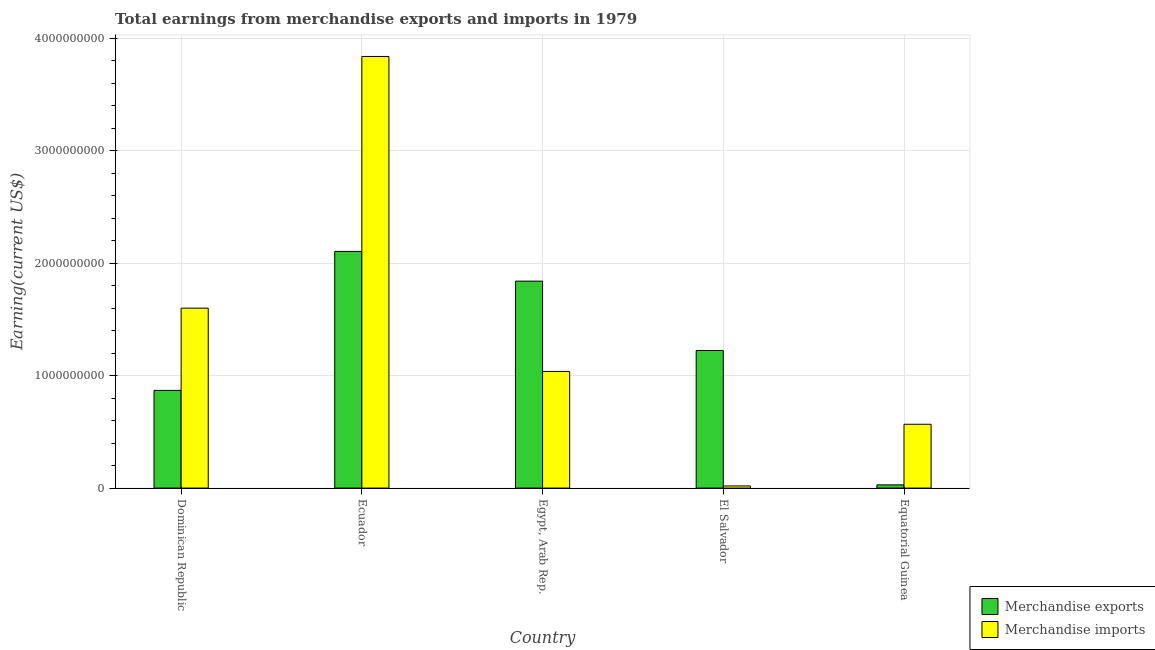How many groups of bars are there?
Your answer should be very brief. 5. What is the label of the 5th group of bars from the left?
Offer a very short reply. Equatorial Guinea. In how many cases, is the number of bars for a given country not equal to the number of legend labels?
Provide a succinct answer. 0. What is the earnings from merchandise imports in Equatorial Guinea?
Offer a terse response. 5.67e+08. Across all countries, what is the maximum earnings from merchandise exports?
Ensure brevity in your answer.  2.10e+09. Across all countries, what is the minimum earnings from merchandise imports?
Your answer should be compact. 1.91e+07. In which country was the earnings from merchandise exports maximum?
Make the answer very short. Ecuador. In which country was the earnings from merchandise imports minimum?
Give a very brief answer. El Salvador. What is the total earnings from merchandise exports in the graph?
Give a very brief answer. 6.06e+09. What is the difference between the earnings from merchandise exports in Ecuador and that in Egypt, Arab Rep.?
Give a very brief answer. 2.64e+08. What is the difference between the earnings from merchandise exports in El Salvador and the earnings from merchandise imports in Dominican Republic?
Provide a succinct answer. -3.77e+08. What is the average earnings from merchandise exports per country?
Give a very brief answer. 1.21e+09. What is the difference between the earnings from merchandise exports and earnings from merchandise imports in Equatorial Guinea?
Provide a succinct answer. -5.39e+08. What is the ratio of the earnings from merchandise imports in Dominican Republic to that in Equatorial Guinea?
Ensure brevity in your answer.  2.82. What is the difference between the highest and the second highest earnings from merchandise imports?
Provide a short and direct response. 2.24e+09. What is the difference between the highest and the lowest earnings from merchandise imports?
Offer a very short reply. 3.82e+09. In how many countries, is the earnings from merchandise imports greater than the average earnings from merchandise imports taken over all countries?
Your answer should be compact. 2. Is the sum of the earnings from merchandise exports in Ecuador and Egypt, Arab Rep. greater than the maximum earnings from merchandise imports across all countries?
Offer a terse response. Yes. What does the 1st bar from the right in Egypt, Arab Rep. represents?
Give a very brief answer. Merchandise imports. Are all the bars in the graph horizontal?
Your response must be concise. No. How many countries are there in the graph?
Ensure brevity in your answer.  5. Are the values on the major ticks of Y-axis written in scientific E-notation?
Your response must be concise. No. Does the graph contain any zero values?
Provide a succinct answer. No. Does the graph contain grids?
Keep it short and to the point. Yes. How many legend labels are there?
Ensure brevity in your answer.  2. How are the legend labels stacked?
Offer a terse response. Vertical. What is the title of the graph?
Your response must be concise. Total earnings from merchandise exports and imports in 1979. Does "Birth rate" appear as one of the legend labels in the graph?
Keep it short and to the point. No. What is the label or title of the X-axis?
Your answer should be compact. Country. What is the label or title of the Y-axis?
Provide a succinct answer. Earning(current US$). What is the Earning(current US$) of Merchandise exports in Dominican Republic?
Give a very brief answer. 8.69e+08. What is the Earning(current US$) of Merchandise imports in Dominican Republic?
Ensure brevity in your answer.  1.60e+09. What is the Earning(current US$) in Merchandise exports in Ecuador?
Your answer should be very brief. 2.10e+09. What is the Earning(current US$) in Merchandise imports in Ecuador?
Keep it short and to the point. 3.84e+09. What is the Earning(current US$) of Merchandise exports in Egypt, Arab Rep.?
Give a very brief answer. 1.84e+09. What is the Earning(current US$) of Merchandise imports in Egypt, Arab Rep.?
Your response must be concise. 1.04e+09. What is the Earning(current US$) in Merchandise exports in El Salvador?
Give a very brief answer. 1.22e+09. What is the Earning(current US$) in Merchandise imports in El Salvador?
Provide a succinct answer. 1.91e+07. What is the Earning(current US$) of Merchandise exports in Equatorial Guinea?
Offer a terse response. 2.87e+07. What is the Earning(current US$) of Merchandise imports in Equatorial Guinea?
Provide a succinct answer. 5.67e+08. Across all countries, what is the maximum Earning(current US$) of Merchandise exports?
Provide a short and direct response. 2.10e+09. Across all countries, what is the maximum Earning(current US$) in Merchandise imports?
Your response must be concise. 3.84e+09. Across all countries, what is the minimum Earning(current US$) of Merchandise exports?
Offer a terse response. 2.87e+07. Across all countries, what is the minimum Earning(current US$) in Merchandise imports?
Ensure brevity in your answer.  1.91e+07. What is the total Earning(current US$) in Merchandise exports in the graph?
Your answer should be compact. 6.06e+09. What is the total Earning(current US$) in Merchandise imports in the graph?
Your answer should be compact. 7.06e+09. What is the difference between the Earning(current US$) of Merchandise exports in Dominican Republic and that in Ecuador?
Keep it short and to the point. -1.24e+09. What is the difference between the Earning(current US$) in Merchandise imports in Dominican Republic and that in Ecuador?
Offer a terse response. -2.24e+09. What is the difference between the Earning(current US$) in Merchandise exports in Dominican Republic and that in Egypt, Arab Rep.?
Your answer should be very brief. -9.71e+08. What is the difference between the Earning(current US$) in Merchandise imports in Dominican Republic and that in Egypt, Arab Rep.?
Give a very brief answer. 5.63e+08. What is the difference between the Earning(current US$) of Merchandise exports in Dominican Republic and that in El Salvador?
Provide a succinct answer. -3.55e+08. What is the difference between the Earning(current US$) in Merchandise imports in Dominican Republic and that in El Salvador?
Give a very brief answer. 1.58e+09. What is the difference between the Earning(current US$) in Merchandise exports in Dominican Republic and that in Equatorial Guinea?
Provide a short and direct response. 8.40e+08. What is the difference between the Earning(current US$) in Merchandise imports in Dominican Republic and that in Equatorial Guinea?
Provide a succinct answer. 1.03e+09. What is the difference between the Earning(current US$) in Merchandise exports in Ecuador and that in Egypt, Arab Rep.?
Make the answer very short. 2.64e+08. What is the difference between the Earning(current US$) in Merchandise imports in Ecuador and that in Egypt, Arab Rep.?
Make the answer very short. 2.80e+09. What is the difference between the Earning(current US$) in Merchandise exports in Ecuador and that in El Salvador?
Your answer should be very brief. 8.81e+08. What is the difference between the Earning(current US$) in Merchandise imports in Ecuador and that in El Salvador?
Give a very brief answer. 3.82e+09. What is the difference between the Earning(current US$) in Merchandise exports in Ecuador and that in Equatorial Guinea?
Provide a short and direct response. 2.08e+09. What is the difference between the Earning(current US$) in Merchandise imports in Ecuador and that in Equatorial Guinea?
Ensure brevity in your answer.  3.27e+09. What is the difference between the Earning(current US$) of Merchandise exports in Egypt, Arab Rep. and that in El Salvador?
Make the answer very short. 6.17e+08. What is the difference between the Earning(current US$) of Merchandise imports in Egypt, Arab Rep. and that in El Salvador?
Your response must be concise. 1.02e+09. What is the difference between the Earning(current US$) in Merchandise exports in Egypt, Arab Rep. and that in Equatorial Guinea?
Make the answer very short. 1.81e+09. What is the difference between the Earning(current US$) in Merchandise imports in Egypt, Arab Rep. and that in Equatorial Guinea?
Keep it short and to the point. 4.70e+08. What is the difference between the Earning(current US$) of Merchandise exports in El Salvador and that in Equatorial Guinea?
Provide a succinct answer. 1.19e+09. What is the difference between the Earning(current US$) of Merchandise imports in El Salvador and that in Equatorial Guinea?
Your answer should be very brief. -5.48e+08. What is the difference between the Earning(current US$) of Merchandise exports in Dominican Republic and the Earning(current US$) of Merchandise imports in Ecuador?
Offer a very short reply. -2.97e+09. What is the difference between the Earning(current US$) of Merchandise exports in Dominican Republic and the Earning(current US$) of Merchandise imports in Egypt, Arab Rep.?
Provide a short and direct response. -1.68e+08. What is the difference between the Earning(current US$) of Merchandise exports in Dominican Republic and the Earning(current US$) of Merchandise imports in El Salvador?
Your response must be concise. 8.49e+08. What is the difference between the Earning(current US$) of Merchandise exports in Dominican Republic and the Earning(current US$) of Merchandise imports in Equatorial Guinea?
Your answer should be very brief. 3.01e+08. What is the difference between the Earning(current US$) in Merchandise exports in Ecuador and the Earning(current US$) in Merchandise imports in Egypt, Arab Rep.?
Your answer should be very brief. 1.07e+09. What is the difference between the Earning(current US$) of Merchandise exports in Ecuador and the Earning(current US$) of Merchandise imports in El Salvador?
Make the answer very short. 2.09e+09. What is the difference between the Earning(current US$) in Merchandise exports in Ecuador and the Earning(current US$) in Merchandise imports in Equatorial Guinea?
Provide a succinct answer. 1.54e+09. What is the difference between the Earning(current US$) in Merchandise exports in Egypt, Arab Rep. and the Earning(current US$) in Merchandise imports in El Salvador?
Offer a terse response. 1.82e+09. What is the difference between the Earning(current US$) of Merchandise exports in Egypt, Arab Rep. and the Earning(current US$) of Merchandise imports in Equatorial Guinea?
Provide a succinct answer. 1.27e+09. What is the difference between the Earning(current US$) in Merchandise exports in El Salvador and the Earning(current US$) in Merchandise imports in Equatorial Guinea?
Ensure brevity in your answer.  6.56e+08. What is the average Earning(current US$) in Merchandise exports per country?
Make the answer very short. 1.21e+09. What is the average Earning(current US$) of Merchandise imports per country?
Your answer should be compact. 1.41e+09. What is the difference between the Earning(current US$) in Merchandise exports and Earning(current US$) in Merchandise imports in Dominican Republic?
Your answer should be very brief. -7.31e+08. What is the difference between the Earning(current US$) in Merchandise exports and Earning(current US$) in Merchandise imports in Ecuador?
Your answer should be very brief. -1.73e+09. What is the difference between the Earning(current US$) of Merchandise exports and Earning(current US$) of Merchandise imports in Egypt, Arab Rep.?
Your answer should be compact. 8.03e+08. What is the difference between the Earning(current US$) of Merchandise exports and Earning(current US$) of Merchandise imports in El Salvador?
Give a very brief answer. 1.20e+09. What is the difference between the Earning(current US$) in Merchandise exports and Earning(current US$) in Merchandise imports in Equatorial Guinea?
Make the answer very short. -5.39e+08. What is the ratio of the Earning(current US$) of Merchandise exports in Dominican Republic to that in Ecuador?
Your answer should be compact. 0.41. What is the ratio of the Earning(current US$) of Merchandise imports in Dominican Republic to that in Ecuador?
Give a very brief answer. 0.42. What is the ratio of the Earning(current US$) of Merchandise exports in Dominican Republic to that in Egypt, Arab Rep.?
Your answer should be very brief. 0.47. What is the ratio of the Earning(current US$) in Merchandise imports in Dominican Republic to that in Egypt, Arab Rep.?
Provide a succinct answer. 1.54. What is the ratio of the Earning(current US$) of Merchandise exports in Dominican Republic to that in El Salvador?
Keep it short and to the point. 0.71. What is the ratio of the Earning(current US$) of Merchandise imports in Dominican Republic to that in El Salvador?
Offer a very short reply. 83.71. What is the ratio of the Earning(current US$) in Merchandise exports in Dominican Republic to that in Equatorial Guinea?
Make the answer very short. 30.24. What is the ratio of the Earning(current US$) of Merchandise imports in Dominican Republic to that in Equatorial Guinea?
Make the answer very short. 2.82. What is the ratio of the Earning(current US$) in Merchandise exports in Ecuador to that in Egypt, Arab Rep.?
Offer a terse response. 1.14. What is the ratio of the Earning(current US$) in Merchandise imports in Ecuador to that in Egypt, Arab Rep.?
Ensure brevity in your answer.  3.7. What is the ratio of the Earning(current US$) in Merchandise exports in Ecuador to that in El Salvador?
Provide a succinct answer. 1.72. What is the ratio of the Earning(current US$) of Merchandise imports in Ecuador to that in El Salvador?
Offer a very short reply. 200.79. What is the ratio of the Earning(current US$) of Merchandise exports in Ecuador to that in Equatorial Guinea?
Your response must be concise. 73.27. What is the ratio of the Earning(current US$) in Merchandise imports in Ecuador to that in Equatorial Guinea?
Provide a succinct answer. 6.76. What is the ratio of the Earning(current US$) in Merchandise exports in Egypt, Arab Rep. to that in El Salvador?
Offer a very short reply. 1.5. What is the ratio of the Earning(current US$) of Merchandise imports in Egypt, Arab Rep. to that in El Salvador?
Make the answer very short. 54.27. What is the ratio of the Earning(current US$) of Merchandise exports in Egypt, Arab Rep. to that in Equatorial Guinea?
Provide a short and direct response. 64.06. What is the ratio of the Earning(current US$) of Merchandise imports in Egypt, Arab Rep. to that in Equatorial Guinea?
Provide a succinct answer. 1.83. What is the ratio of the Earning(current US$) of Merchandise exports in El Salvador to that in Equatorial Guinea?
Offer a very short reply. 42.59. What is the ratio of the Earning(current US$) of Merchandise imports in El Salvador to that in Equatorial Guinea?
Give a very brief answer. 0.03. What is the difference between the highest and the second highest Earning(current US$) of Merchandise exports?
Offer a terse response. 2.64e+08. What is the difference between the highest and the second highest Earning(current US$) of Merchandise imports?
Your response must be concise. 2.24e+09. What is the difference between the highest and the lowest Earning(current US$) of Merchandise exports?
Provide a short and direct response. 2.08e+09. What is the difference between the highest and the lowest Earning(current US$) of Merchandise imports?
Offer a terse response. 3.82e+09. 